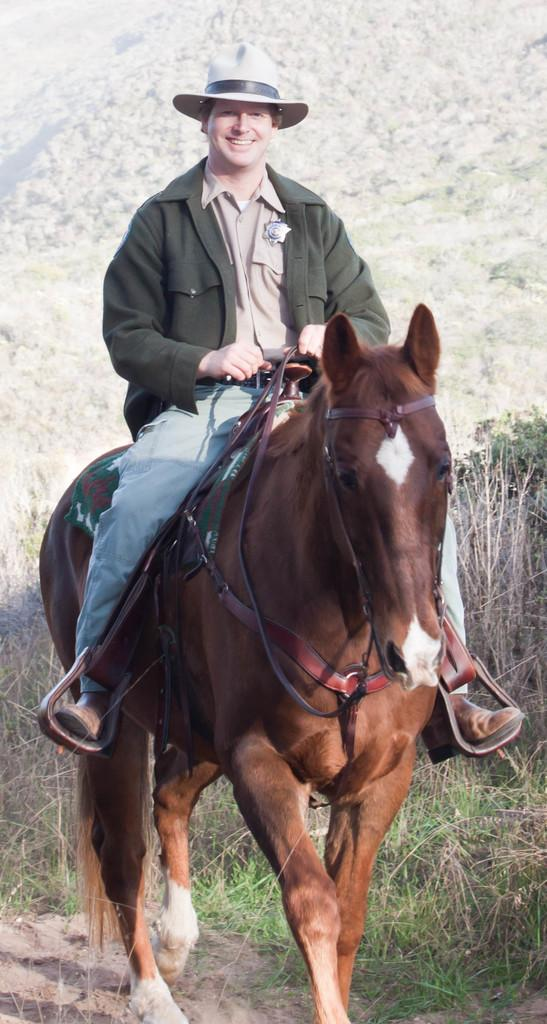What is the man doing in the image? The man is sitting on a horse in the image. What is the man's facial expression? The man is smiling in the image. What is the man wearing on his head? The man is wearing a hat in the image. What can be seen in the background of the image? There is a hill, a tree, plants, and grass in the background of the image. How many oranges can be seen hanging from the tree in the image? There are no oranges visible in the image; the tree in the background does not have any oranges. What type of view can be seen from the top of the hill in the image? The image does not show a view from the top of the hill, as it only depicts the hill in the background. 